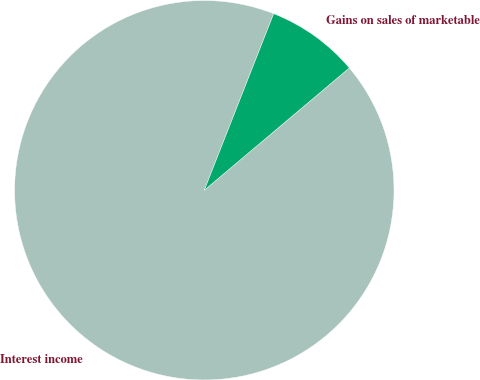Convert chart to OTSL. <chart><loc_0><loc_0><loc_500><loc_500><pie_chart><fcel>Interest income<fcel>Gains on sales of marketable<nl><fcel>92.11%<fcel>7.89%<nl></chart> 